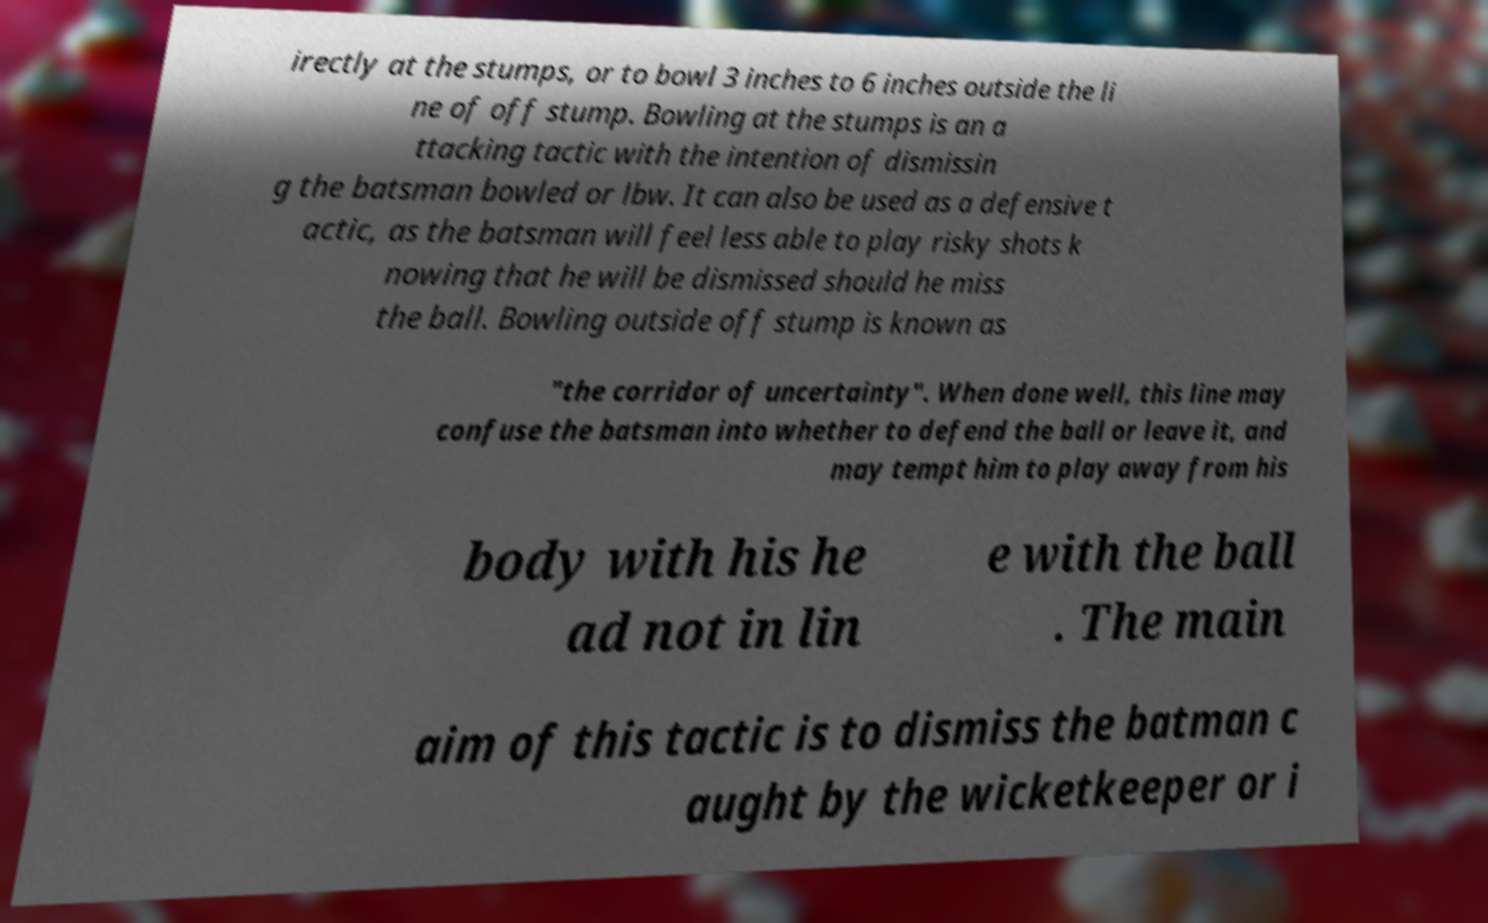Please identify and transcribe the text found in this image. irectly at the stumps, or to bowl 3 inches to 6 inches outside the li ne of off stump. Bowling at the stumps is an a ttacking tactic with the intention of dismissin g the batsman bowled or lbw. It can also be used as a defensive t actic, as the batsman will feel less able to play risky shots k nowing that he will be dismissed should he miss the ball. Bowling outside off stump is known as "the corridor of uncertainty". When done well, this line may confuse the batsman into whether to defend the ball or leave it, and may tempt him to play away from his body with his he ad not in lin e with the ball . The main aim of this tactic is to dismiss the batman c aught by the wicketkeeper or i 